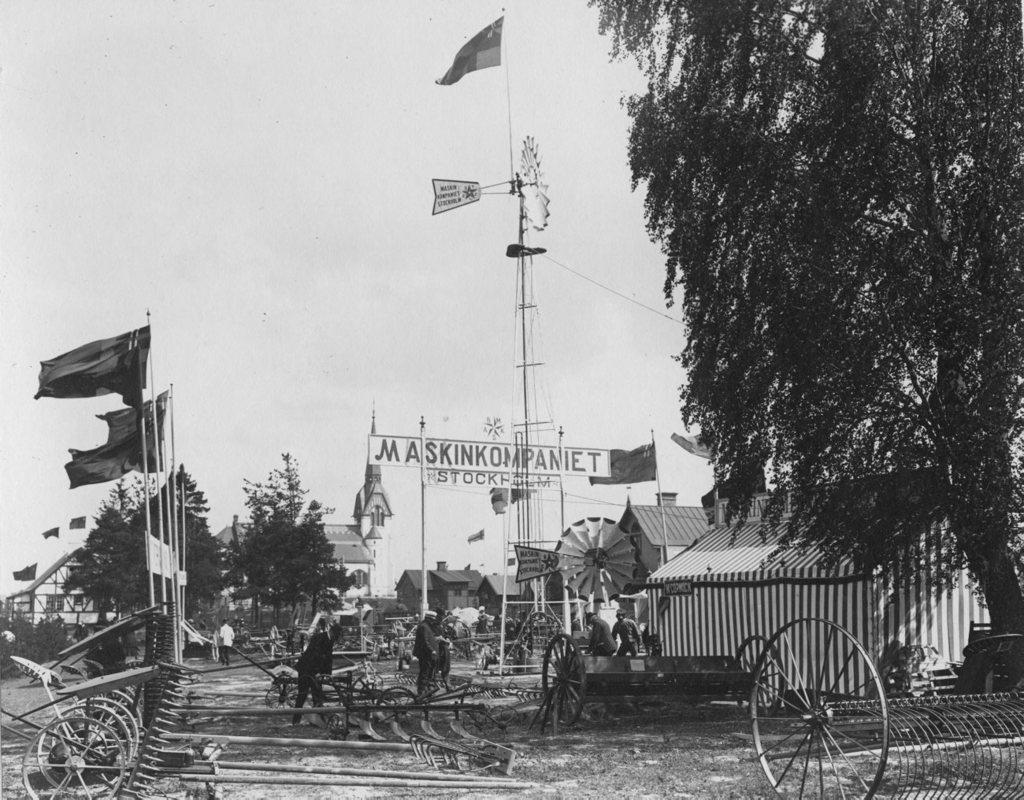What type of structures can be seen in the image? There are houses, towers, and posters visible in the image. What objects have wheels in the image? The image does not show any specific objects with wheels. What can be seen flying in the image? There are flags visible in the image, which are flying. How many people are present in the image? There are people in the image, but the exact number is not specified. What type of vegetation is present in the image? There are trees visible in the image. What type of terrain is visible in the image? There is land visible in the image. Where are the trees located in the image? There are trees on the right side of the image. What is visible on the right side of the image besides trees? The sky is visible on the right side of the image. Can you see any dinosaurs roaming around in the image? No, there are no dinosaurs present in the image. What type of lift is used to transport people in the image? There is no lift visible in the image. What is the hammer being used for in the image? There is no hammer present in the image. 